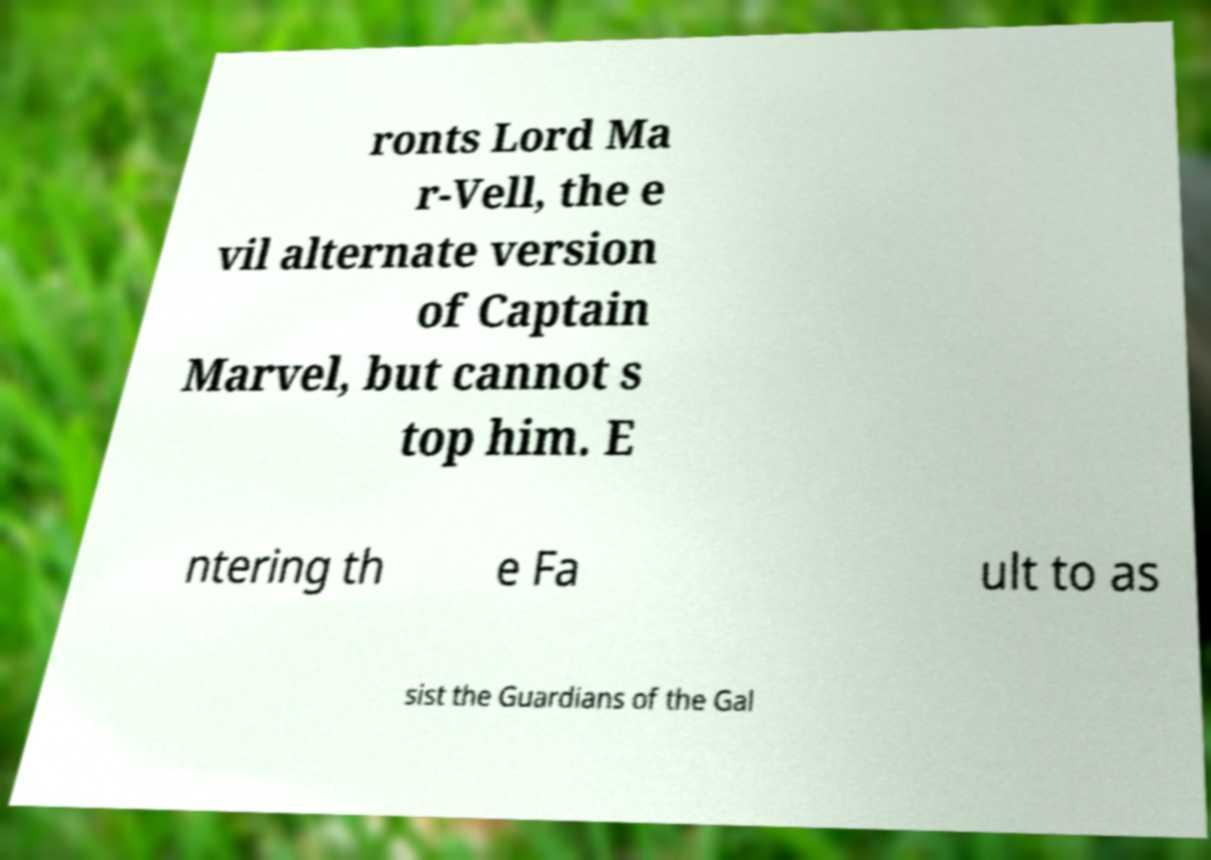Please read and relay the text visible in this image. What does it say? ronts Lord Ma r-Vell, the e vil alternate version of Captain Marvel, but cannot s top him. E ntering th e Fa ult to as sist the Guardians of the Gal 